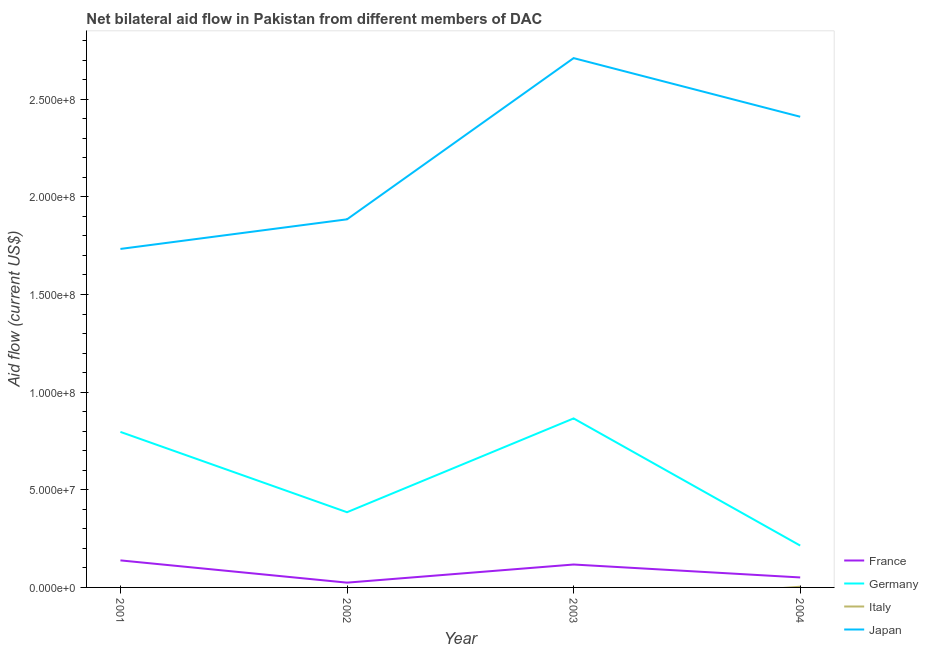How many different coloured lines are there?
Your answer should be very brief. 4. What is the amount of aid given by germany in 2001?
Provide a succinct answer. 7.96e+07. Across all years, what is the maximum amount of aid given by france?
Make the answer very short. 1.38e+07. Across all years, what is the minimum amount of aid given by italy?
Provide a succinct answer. 0. In which year was the amount of aid given by france maximum?
Make the answer very short. 2001. What is the total amount of aid given by italy in the graph?
Provide a short and direct response. 3.70e+05. What is the difference between the amount of aid given by germany in 2001 and that in 2002?
Offer a very short reply. 4.11e+07. What is the difference between the amount of aid given by germany in 2002 and the amount of aid given by france in 2004?
Provide a succinct answer. 3.34e+07. What is the average amount of aid given by germany per year?
Give a very brief answer. 5.65e+07. In the year 2004, what is the difference between the amount of aid given by japan and amount of aid given by italy?
Give a very brief answer. 2.41e+08. What is the ratio of the amount of aid given by france in 2001 to that in 2003?
Your answer should be very brief. 1.18. Is the amount of aid given by france in 2001 less than that in 2002?
Offer a terse response. No. Is the difference between the amount of aid given by germany in 2001 and 2003 greater than the difference between the amount of aid given by japan in 2001 and 2003?
Your answer should be compact. Yes. What is the difference between the highest and the second highest amount of aid given by germany?
Make the answer very short. 6.90e+06. What is the difference between the highest and the lowest amount of aid given by germany?
Offer a very short reply. 6.51e+07. In how many years, is the amount of aid given by italy greater than the average amount of aid given by italy taken over all years?
Provide a succinct answer. 1. Is it the case that in every year, the sum of the amount of aid given by france and amount of aid given by germany is greater than the sum of amount of aid given by japan and amount of aid given by italy?
Your response must be concise. No. Is it the case that in every year, the sum of the amount of aid given by france and amount of aid given by germany is greater than the amount of aid given by italy?
Provide a short and direct response. Yes. Does the amount of aid given by france monotonically increase over the years?
Provide a short and direct response. No. Is the amount of aid given by germany strictly less than the amount of aid given by italy over the years?
Make the answer very short. No. How many lines are there?
Ensure brevity in your answer.  4. What is the difference between two consecutive major ticks on the Y-axis?
Your answer should be very brief. 5.00e+07. Are the values on the major ticks of Y-axis written in scientific E-notation?
Ensure brevity in your answer.  Yes. Does the graph contain any zero values?
Make the answer very short. Yes. Does the graph contain grids?
Offer a very short reply. No. Where does the legend appear in the graph?
Your answer should be very brief. Bottom right. How many legend labels are there?
Give a very brief answer. 4. What is the title of the graph?
Keep it short and to the point. Net bilateral aid flow in Pakistan from different members of DAC. Does "Gender equality" appear as one of the legend labels in the graph?
Your answer should be compact. No. What is the Aid flow (current US$) of France in 2001?
Keep it short and to the point. 1.38e+07. What is the Aid flow (current US$) of Germany in 2001?
Your answer should be compact. 7.96e+07. What is the Aid flow (current US$) of Japan in 2001?
Your answer should be very brief. 1.73e+08. What is the Aid flow (current US$) in France in 2002?
Give a very brief answer. 2.45e+06. What is the Aid flow (current US$) in Germany in 2002?
Offer a very short reply. 3.85e+07. What is the Aid flow (current US$) in Italy in 2002?
Offer a terse response. 0. What is the Aid flow (current US$) in Japan in 2002?
Offer a terse response. 1.88e+08. What is the Aid flow (current US$) of France in 2003?
Offer a terse response. 1.17e+07. What is the Aid flow (current US$) of Germany in 2003?
Give a very brief answer. 8.65e+07. What is the Aid flow (current US$) in Italy in 2003?
Offer a very short reply. 0. What is the Aid flow (current US$) in Japan in 2003?
Make the answer very short. 2.71e+08. What is the Aid flow (current US$) of France in 2004?
Your response must be concise. 5.11e+06. What is the Aid flow (current US$) in Germany in 2004?
Provide a short and direct response. 2.14e+07. What is the Aid flow (current US$) of Japan in 2004?
Provide a succinct answer. 2.41e+08. Across all years, what is the maximum Aid flow (current US$) in France?
Make the answer very short. 1.38e+07. Across all years, what is the maximum Aid flow (current US$) in Germany?
Offer a very short reply. 8.65e+07. Across all years, what is the maximum Aid flow (current US$) in Japan?
Give a very brief answer. 2.71e+08. Across all years, what is the minimum Aid flow (current US$) in France?
Keep it short and to the point. 2.45e+06. Across all years, what is the minimum Aid flow (current US$) of Germany?
Provide a succinct answer. 2.14e+07. Across all years, what is the minimum Aid flow (current US$) in Japan?
Ensure brevity in your answer.  1.73e+08. What is the total Aid flow (current US$) in France in the graph?
Your answer should be compact. 3.31e+07. What is the total Aid flow (current US$) in Germany in the graph?
Give a very brief answer. 2.26e+08. What is the total Aid flow (current US$) in Italy in the graph?
Your answer should be very brief. 3.70e+05. What is the total Aid flow (current US$) of Japan in the graph?
Keep it short and to the point. 8.74e+08. What is the difference between the Aid flow (current US$) in France in 2001 and that in 2002?
Keep it short and to the point. 1.14e+07. What is the difference between the Aid flow (current US$) of Germany in 2001 and that in 2002?
Keep it short and to the point. 4.11e+07. What is the difference between the Aid flow (current US$) of Japan in 2001 and that in 2002?
Offer a very short reply. -1.52e+07. What is the difference between the Aid flow (current US$) in France in 2001 and that in 2003?
Keep it short and to the point. 2.12e+06. What is the difference between the Aid flow (current US$) in Germany in 2001 and that in 2003?
Provide a short and direct response. -6.90e+06. What is the difference between the Aid flow (current US$) of Japan in 2001 and that in 2003?
Make the answer very short. -9.77e+07. What is the difference between the Aid flow (current US$) of France in 2001 and that in 2004?
Your response must be concise. 8.74e+06. What is the difference between the Aid flow (current US$) of Germany in 2001 and that in 2004?
Offer a very short reply. 5.82e+07. What is the difference between the Aid flow (current US$) of Japan in 2001 and that in 2004?
Your answer should be compact. -6.77e+07. What is the difference between the Aid flow (current US$) of France in 2002 and that in 2003?
Offer a very short reply. -9.28e+06. What is the difference between the Aid flow (current US$) of Germany in 2002 and that in 2003?
Your response must be concise. -4.80e+07. What is the difference between the Aid flow (current US$) in Japan in 2002 and that in 2003?
Make the answer very short. -8.26e+07. What is the difference between the Aid flow (current US$) in France in 2002 and that in 2004?
Your answer should be compact. -2.66e+06. What is the difference between the Aid flow (current US$) of Germany in 2002 and that in 2004?
Ensure brevity in your answer.  1.71e+07. What is the difference between the Aid flow (current US$) in Japan in 2002 and that in 2004?
Offer a terse response. -5.25e+07. What is the difference between the Aid flow (current US$) of France in 2003 and that in 2004?
Keep it short and to the point. 6.62e+06. What is the difference between the Aid flow (current US$) of Germany in 2003 and that in 2004?
Keep it short and to the point. 6.51e+07. What is the difference between the Aid flow (current US$) in Japan in 2003 and that in 2004?
Ensure brevity in your answer.  3.00e+07. What is the difference between the Aid flow (current US$) in France in 2001 and the Aid flow (current US$) in Germany in 2002?
Give a very brief answer. -2.47e+07. What is the difference between the Aid flow (current US$) in France in 2001 and the Aid flow (current US$) in Japan in 2002?
Keep it short and to the point. -1.75e+08. What is the difference between the Aid flow (current US$) in Germany in 2001 and the Aid flow (current US$) in Japan in 2002?
Offer a very short reply. -1.09e+08. What is the difference between the Aid flow (current US$) in France in 2001 and the Aid flow (current US$) in Germany in 2003?
Make the answer very short. -7.27e+07. What is the difference between the Aid flow (current US$) in France in 2001 and the Aid flow (current US$) in Japan in 2003?
Provide a short and direct response. -2.57e+08. What is the difference between the Aid flow (current US$) in Germany in 2001 and the Aid flow (current US$) in Japan in 2003?
Offer a very short reply. -1.91e+08. What is the difference between the Aid flow (current US$) in France in 2001 and the Aid flow (current US$) in Germany in 2004?
Your answer should be compact. -7.58e+06. What is the difference between the Aid flow (current US$) in France in 2001 and the Aid flow (current US$) in Italy in 2004?
Your answer should be very brief. 1.35e+07. What is the difference between the Aid flow (current US$) in France in 2001 and the Aid flow (current US$) in Japan in 2004?
Offer a very short reply. -2.27e+08. What is the difference between the Aid flow (current US$) in Germany in 2001 and the Aid flow (current US$) in Italy in 2004?
Your answer should be very brief. 7.93e+07. What is the difference between the Aid flow (current US$) in Germany in 2001 and the Aid flow (current US$) in Japan in 2004?
Offer a terse response. -1.61e+08. What is the difference between the Aid flow (current US$) of France in 2002 and the Aid flow (current US$) of Germany in 2003?
Give a very brief answer. -8.41e+07. What is the difference between the Aid flow (current US$) in France in 2002 and the Aid flow (current US$) in Japan in 2003?
Offer a very short reply. -2.69e+08. What is the difference between the Aid flow (current US$) in Germany in 2002 and the Aid flow (current US$) in Japan in 2003?
Ensure brevity in your answer.  -2.33e+08. What is the difference between the Aid flow (current US$) in France in 2002 and the Aid flow (current US$) in Germany in 2004?
Offer a very short reply. -1.90e+07. What is the difference between the Aid flow (current US$) in France in 2002 and the Aid flow (current US$) in Italy in 2004?
Offer a terse response. 2.08e+06. What is the difference between the Aid flow (current US$) of France in 2002 and the Aid flow (current US$) of Japan in 2004?
Your answer should be very brief. -2.39e+08. What is the difference between the Aid flow (current US$) of Germany in 2002 and the Aid flow (current US$) of Italy in 2004?
Keep it short and to the point. 3.81e+07. What is the difference between the Aid flow (current US$) in Germany in 2002 and the Aid flow (current US$) in Japan in 2004?
Keep it short and to the point. -2.03e+08. What is the difference between the Aid flow (current US$) of France in 2003 and the Aid flow (current US$) of Germany in 2004?
Ensure brevity in your answer.  -9.70e+06. What is the difference between the Aid flow (current US$) in France in 2003 and the Aid flow (current US$) in Italy in 2004?
Your answer should be very brief. 1.14e+07. What is the difference between the Aid flow (current US$) of France in 2003 and the Aid flow (current US$) of Japan in 2004?
Give a very brief answer. -2.29e+08. What is the difference between the Aid flow (current US$) in Germany in 2003 and the Aid flow (current US$) in Italy in 2004?
Offer a very short reply. 8.62e+07. What is the difference between the Aid flow (current US$) of Germany in 2003 and the Aid flow (current US$) of Japan in 2004?
Give a very brief answer. -1.54e+08. What is the average Aid flow (current US$) in France per year?
Provide a short and direct response. 8.28e+06. What is the average Aid flow (current US$) in Germany per year?
Provide a short and direct response. 5.65e+07. What is the average Aid flow (current US$) in Italy per year?
Provide a succinct answer. 9.25e+04. What is the average Aid flow (current US$) in Japan per year?
Offer a terse response. 2.18e+08. In the year 2001, what is the difference between the Aid flow (current US$) of France and Aid flow (current US$) of Germany?
Keep it short and to the point. -6.58e+07. In the year 2001, what is the difference between the Aid flow (current US$) of France and Aid flow (current US$) of Japan?
Offer a very short reply. -1.59e+08. In the year 2001, what is the difference between the Aid flow (current US$) of Germany and Aid flow (current US$) of Japan?
Your response must be concise. -9.37e+07. In the year 2002, what is the difference between the Aid flow (current US$) in France and Aid flow (current US$) in Germany?
Provide a short and direct response. -3.61e+07. In the year 2002, what is the difference between the Aid flow (current US$) in France and Aid flow (current US$) in Japan?
Provide a succinct answer. -1.86e+08. In the year 2002, what is the difference between the Aid flow (current US$) of Germany and Aid flow (current US$) of Japan?
Make the answer very short. -1.50e+08. In the year 2003, what is the difference between the Aid flow (current US$) of France and Aid flow (current US$) of Germany?
Provide a succinct answer. -7.48e+07. In the year 2003, what is the difference between the Aid flow (current US$) in France and Aid flow (current US$) in Japan?
Provide a short and direct response. -2.59e+08. In the year 2003, what is the difference between the Aid flow (current US$) in Germany and Aid flow (current US$) in Japan?
Provide a short and direct response. -1.84e+08. In the year 2004, what is the difference between the Aid flow (current US$) of France and Aid flow (current US$) of Germany?
Your answer should be compact. -1.63e+07. In the year 2004, what is the difference between the Aid flow (current US$) in France and Aid flow (current US$) in Italy?
Give a very brief answer. 4.74e+06. In the year 2004, what is the difference between the Aid flow (current US$) in France and Aid flow (current US$) in Japan?
Your answer should be very brief. -2.36e+08. In the year 2004, what is the difference between the Aid flow (current US$) in Germany and Aid flow (current US$) in Italy?
Provide a succinct answer. 2.11e+07. In the year 2004, what is the difference between the Aid flow (current US$) in Germany and Aid flow (current US$) in Japan?
Your answer should be compact. -2.20e+08. In the year 2004, what is the difference between the Aid flow (current US$) of Italy and Aid flow (current US$) of Japan?
Provide a short and direct response. -2.41e+08. What is the ratio of the Aid flow (current US$) of France in 2001 to that in 2002?
Your answer should be compact. 5.65. What is the ratio of the Aid flow (current US$) in Germany in 2001 to that in 2002?
Make the answer very short. 2.07. What is the ratio of the Aid flow (current US$) of Japan in 2001 to that in 2002?
Your answer should be compact. 0.92. What is the ratio of the Aid flow (current US$) in France in 2001 to that in 2003?
Keep it short and to the point. 1.18. What is the ratio of the Aid flow (current US$) of Germany in 2001 to that in 2003?
Your answer should be compact. 0.92. What is the ratio of the Aid flow (current US$) of Japan in 2001 to that in 2003?
Provide a short and direct response. 0.64. What is the ratio of the Aid flow (current US$) of France in 2001 to that in 2004?
Provide a succinct answer. 2.71. What is the ratio of the Aid flow (current US$) in Germany in 2001 to that in 2004?
Provide a short and direct response. 3.72. What is the ratio of the Aid flow (current US$) in Japan in 2001 to that in 2004?
Provide a short and direct response. 0.72. What is the ratio of the Aid flow (current US$) in France in 2002 to that in 2003?
Give a very brief answer. 0.21. What is the ratio of the Aid flow (current US$) of Germany in 2002 to that in 2003?
Your response must be concise. 0.45. What is the ratio of the Aid flow (current US$) in Japan in 2002 to that in 2003?
Keep it short and to the point. 0.7. What is the ratio of the Aid flow (current US$) in France in 2002 to that in 2004?
Make the answer very short. 0.48. What is the ratio of the Aid flow (current US$) of Germany in 2002 to that in 2004?
Make the answer very short. 1.8. What is the ratio of the Aid flow (current US$) in Japan in 2002 to that in 2004?
Offer a terse response. 0.78. What is the ratio of the Aid flow (current US$) of France in 2003 to that in 2004?
Your answer should be very brief. 2.3. What is the ratio of the Aid flow (current US$) of Germany in 2003 to that in 2004?
Keep it short and to the point. 4.04. What is the ratio of the Aid flow (current US$) in Japan in 2003 to that in 2004?
Your answer should be compact. 1.12. What is the difference between the highest and the second highest Aid flow (current US$) in France?
Keep it short and to the point. 2.12e+06. What is the difference between the highest and the second highest Aid flow (current US$) in Germany?
Offer a terse response. 6.90e+06. What is the difference between the highest and the second highest Aid flow (current US$) of Japan?
Give a very brief answer. 3.00e+07. What is the difference between the highest and the lowest Aid flow (current US$) in France?
Give a very brief answer. 1.14e+07. What is the difference between the highest and the lowest Aid flow (current US$) of Germany?
Keep it short and to the point. 6.51e+07. What is the difference between the highest and the lowest Aid flow (current US$) in Italy?
Provide a succinct answer. 3.70e+05. What is the difference between the highest and the lowest Aid flow (current US$) in Japan?
Make the answer very short. 9.77e+07. 